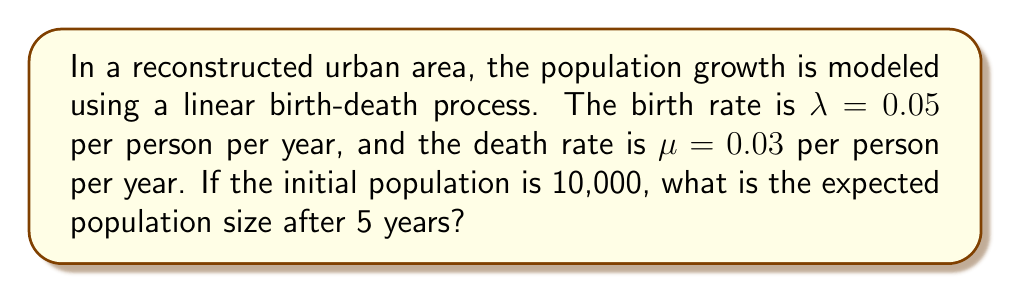Provide a solution to this math problem. To solve this problem, we'll use the following steps:

1. Identify the key parameters:
   - Initial population: $N_0 = 10,000$
   - Birth rate: $\lambda = 0.05$ per person per year
   - Death rate: $\mu = 0.03$ per person per year
   - Time: $t = 5$ years

2. Calculate the net growth rate:
   $r = \lambda - \mu = 0.05 - 0.03 = 0.02$ per person per year

3. Use the formula for expected population size in a linear birth-death process:
   $$E[N_t] = N_0 e^{rt}$$
   Where:
   - $E[N_t]$ is the expected population size at time $t$
   - $N_0$ is the initial population
   - $r$ is the net growth rate
   - $t$ is the time elapsed

4. Substitute the values into the formula:
   $$E[N_5] = 10,000 \cdot e^{0.02 \cdot 5}$$

5. Calculate the result:
   $$E[N_5] = 10,000 \cdot e^{0.1} \approx 10,000 \cdot 1.1052 \approx 11,052$$

Therefore, the expected population size after 5 years is approximately 11,052 people.
Answer: 11,052 people 